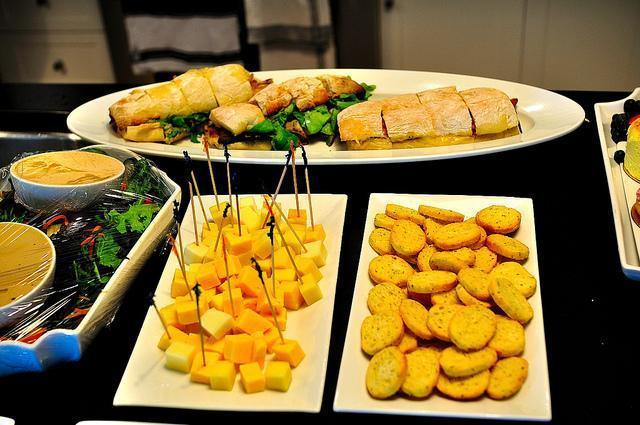How many sandwiches are in the picture?
Give a very brief answer. 3. How many bowls are there?
Give a very brief answer. 2. How many giraffes are there?
Give a very brief answer. 0. 